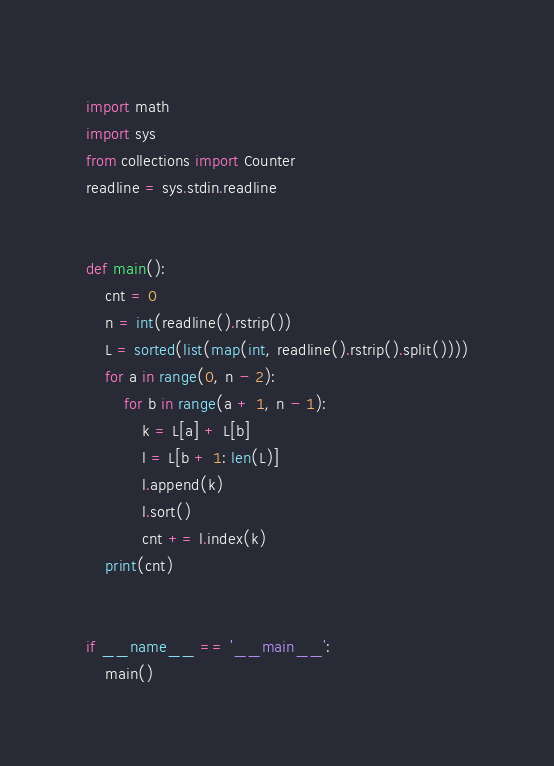Convert code to text. <code><loc_0><loc_0><loc_500><loc_500><_Python_>import math
import sys
from collections import Counter
readline = sys.stdin.readline


def main():
    cnt = 0
    n = int(readline().rstrip())
    L = sorted(list(map(int, readline().rstrip().split())))
    for a in range(0, n - 2):
        for b in range(a + 1, n - 1):
            k = L[a] + L[b]
            l = L[b + 1: len(L)]
            l.append(k)
            l.sort()
            cnt += l.index(k)
    print(cnt)


if __name__ == '__main__':
    main()
</code> 